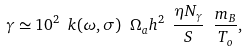Convert formula to latex. <formula><loc_0><loc_0><loc_500><loc_500>\gamma \simeq 1 0 ^ { 2 } \ k ( \omega , \sigma ) \ \Omega _ { a } h ^ { 2 } \ \frac { \eta N _ { \gamma } } { S } \ \frac { m _ { B } } { T _ { o } } ,</formula> 